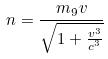<formula> <loc_0><loc_0><loc_500><loc_500>n = \frac { m _ { 9 } v } { \sqrt { 1 + \frac { v ^ { 3 } } { c ^ { 3 } } } }</formula> 